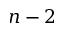<formula> <loc_0><loc_0><loc_500><loc_500>n - 2</formula> 